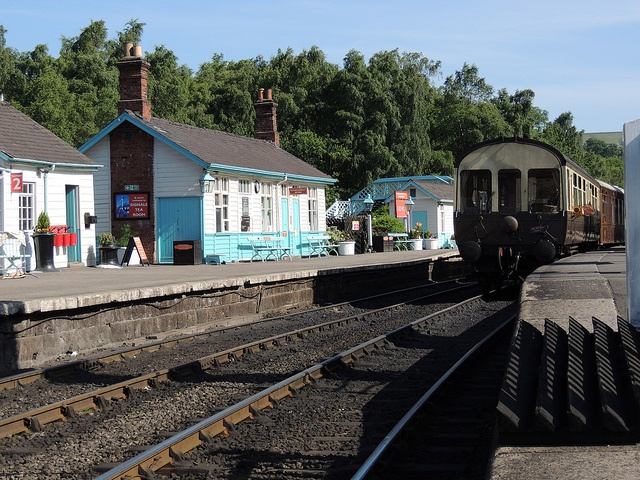Describe the objects in this image and their specific colors. I can see train in lightblue, black, gray, and maroon tones, bench in lightblue, teal, and darkgray tones, potted plant in lightblue, black, white, gray, and darkgray tones, potted plant in lightblue, black, gray, darkgreen, and olive tones, and bench in lightblue, black, and teal tones in this image. 